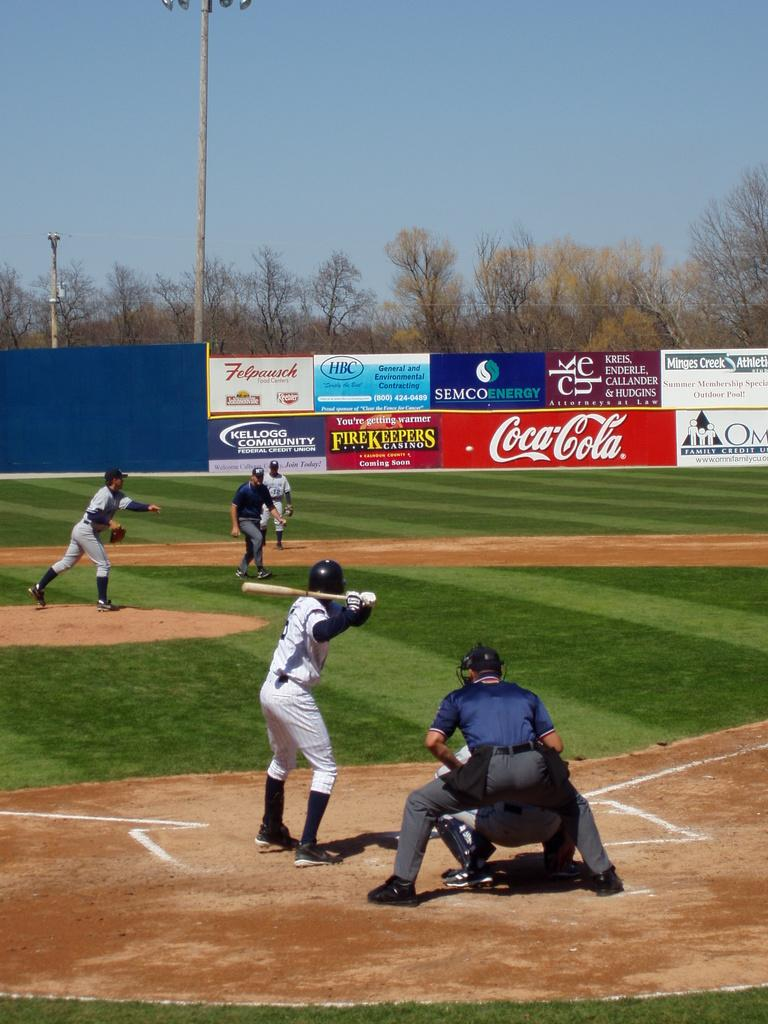<image>
Summarize the visual content of the image. Two baseball teams playing on a field sponsored by Coca-Cola. 